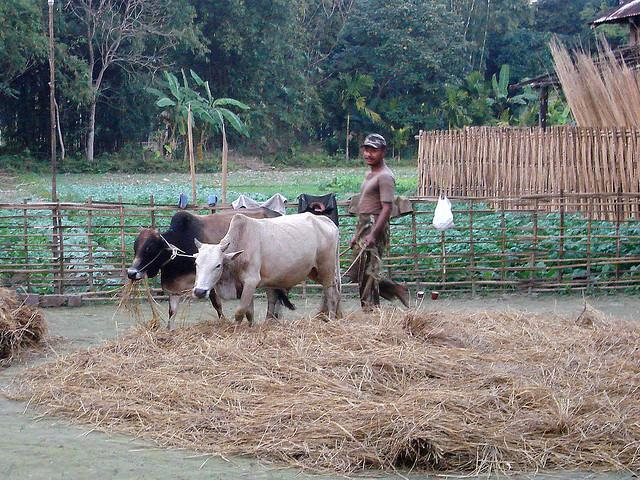What keeps the cattle from eating the garden here? Please explain your reasoning. fencing. Wooden railings can stop cattle from moving to another area. 